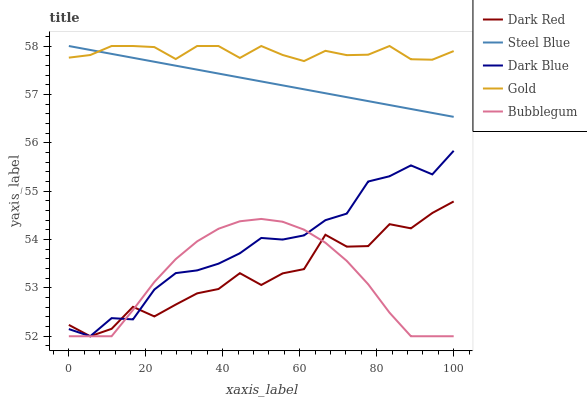Does Bubblegum have the minimum area under the curve?
Answer yes or no. Yes. Does Gold have the maximum area under the curve?
Answer yes or no. Yes. Does Steel Blue have the minimum area under the curve?
Answer yes or no. No. Does Steel Blue have the maximum area under the curve?
Answer yes or no. No. Is Steel Blue the smoothest?
Answer yes or no. Yes. Is Dark Red the roughest?
Answer yes or no. Yes. Is Bubblegum the smoothest?
Answer yes or no. No. Is Bubblegum the roughest?
Answer yes or no. No. Does Dark Red have the lowest value?
Answer yes or no. Yes. Does Steel Blue have the lowest value?
Answer yes or no. No. Does Gold have the highest value?
Answer yes or no. Yes. Does Bubblegum have the highest value?
Answer yes or no. No. Is Bubblegum less than Gold?
Answer yes or no. Yes. Is Steel Blue greater than Dark Red?
Answer yes or no. Yes. Does Dark Red intersect Dark Blue?
Answer yes or no. Yes. Is Dark Red less than Dark Blue?
Answer yes or no. No. Is Dark Red greater than Dark Blue?
Answer yes or no. No. Does Bubblegum intersect Gold?
Answer yes or no. No. 